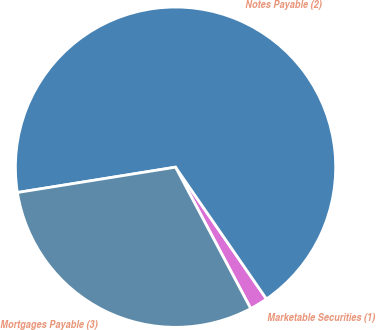<chart> <loc_0><loc_0><loc_500><loc_500><pie_chart><fcel>Marketable Securities (1)<fcel>Notes Payable (2)<fcel>Mortgages Payable (3)<nl><fcel>1.83%<fcel>67.92%<fcel>30.25%<nl></chart> 